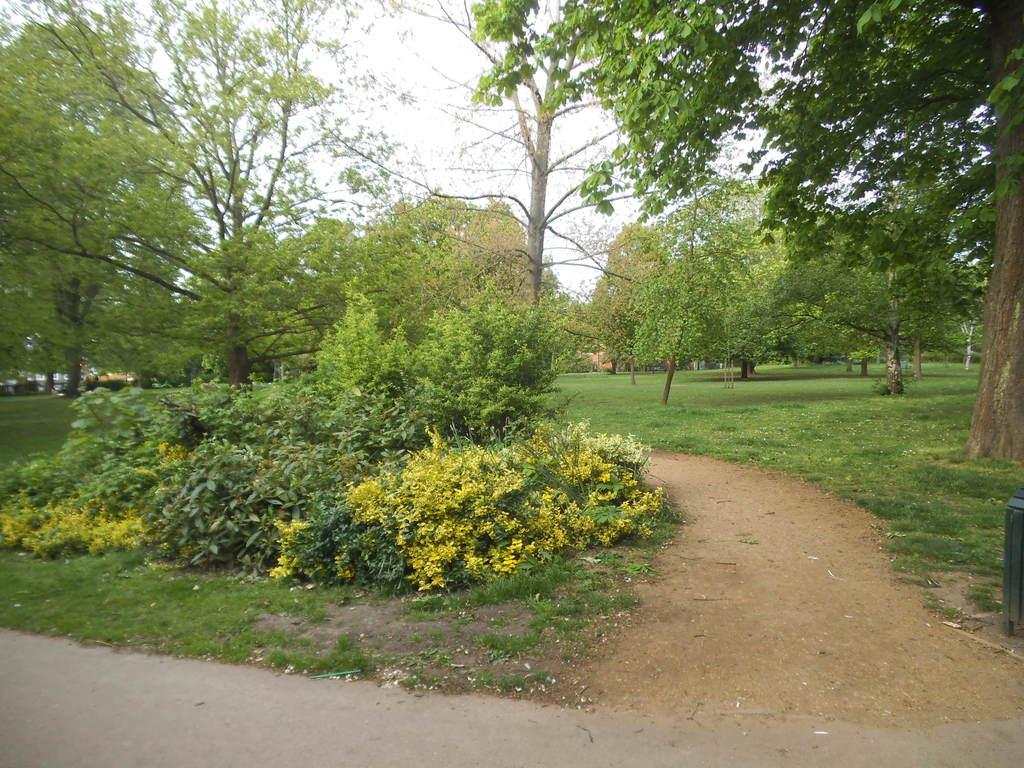What is the main feature of the image? There is a road in the image. What can be seen alongside the road? There are trees and plants in the image. What is visible at the top of the image? The sky is visible at the top of the image. What object is located at the side of the image? There is a box at the side of the image. How many men are seen kicking the box in the image? There are no men or kicking actions present in the image. What type of chalk is used to draw on the road in the image? There is no chalk or drawing on the road in the image. 